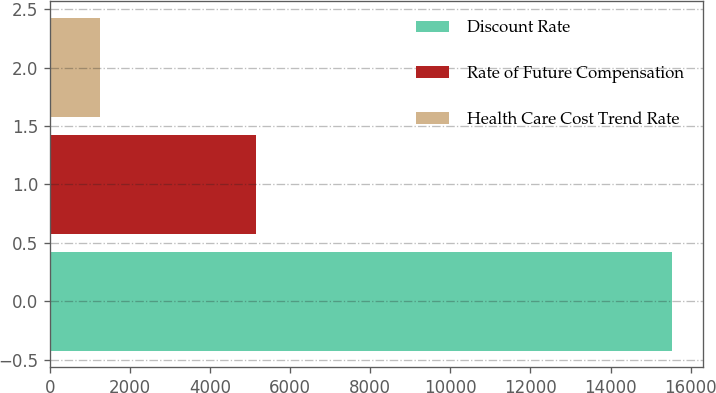Convert chart. <chart><loc_0><loc_0><loc_500><loc_500><bar_chart><fcel>Discount Rate<fcel>Rate of Future Compensation<fcel>Health Care Cost Trend Rate<nl><fcel>15524<fcel>5138<fcel>1249<nl></chart> 